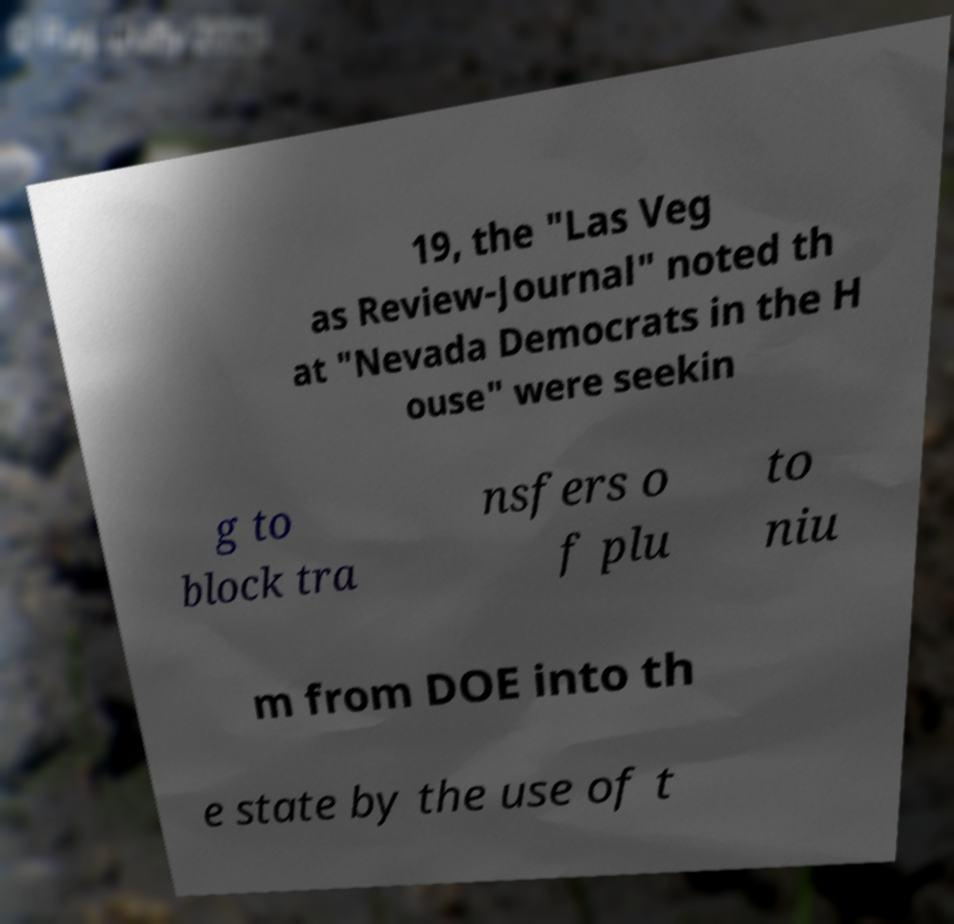What messages or text are displayed in this image? I need them in a readable, typed format. 19, the "Las Veg as Review-Journal" noted th at "Nevada Democrats in the H ouse" were seekin g to block tra nsfers o f plu to niu m from DOE into th e state by the use of t 